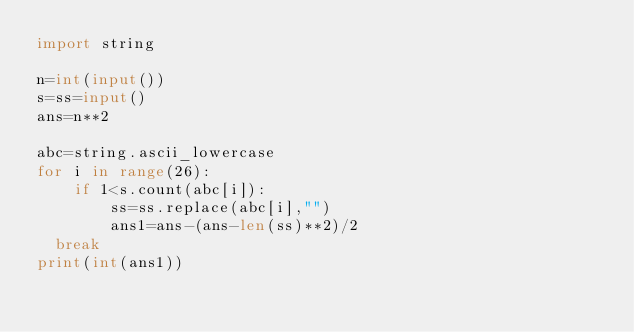<code> <loc_0><loc_0><loc_500><loc_500><_Python_>import string

n=int(input())
s=ss=input()
ans=n**2

abc=string.ascii_lowercase
for i in range(26):
    if 1<s.count(abc[i]):
        ss=ss.replace(abc[i],"")
        ans1=ans-(ans-len(ss)**2)/2
	break        
print(int(ans1))
</code> 